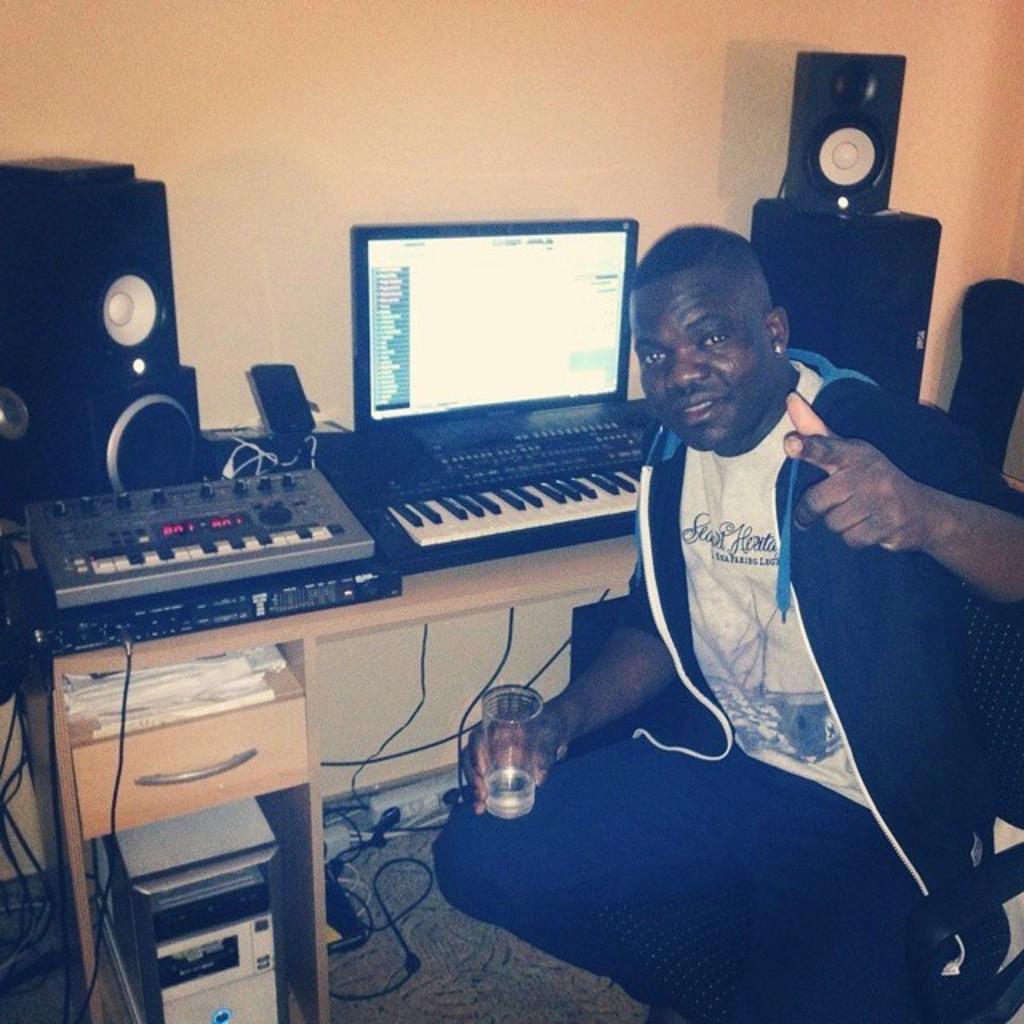Describe this image in one or two sentences. In this image, In the right side there is a man sitting on the chair and he is holding a glass, In the background there is a computer which is in black color and there is a keyboard in white color, There are some speakers in black color, There is a table in yellow color, There is a wall in yellow color. 